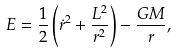Convert formula to latex. <formula><loc_0><loc_0><loc_500><loc_500>E = \frac { 1 } { 2 } \left ( \dot { r } ^ { 2 } + \frac { L ^ { 2 } } { r ^ { 2 } } \right ) - \frac { G M } { r } ,</formula> 